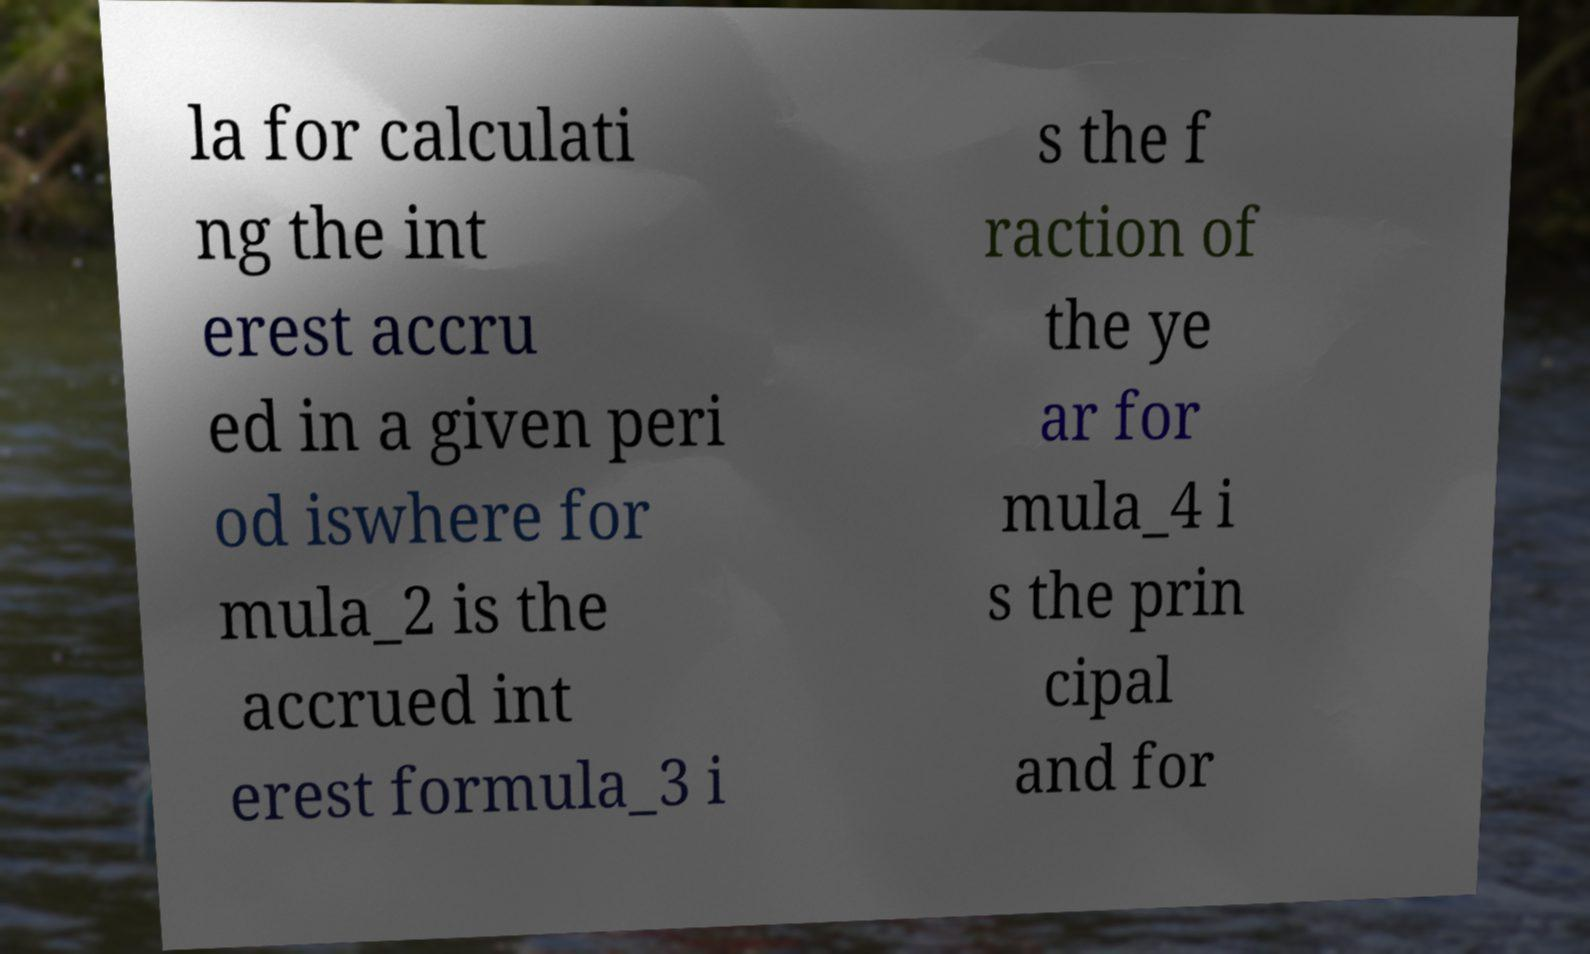There's text embedded in this image that I need extracted. Can you transcribe it verbatim? la for calculati ng the int erest accru ed in a given peri od iswhere for mula_2 is the accrued int erest formula_3 i s the f raction of the ye ar for mula_4 i s the prin cipal and for 